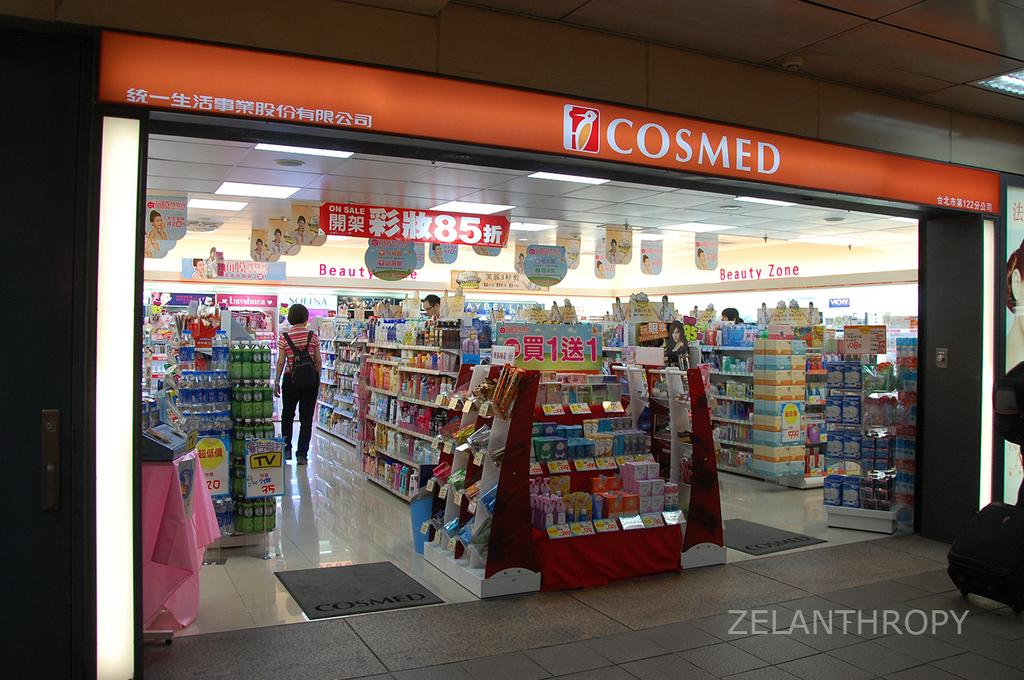<image>
Give a short and clear explanation of the subsequent image. A woman in a striped shirt shops at a Cosmed. 